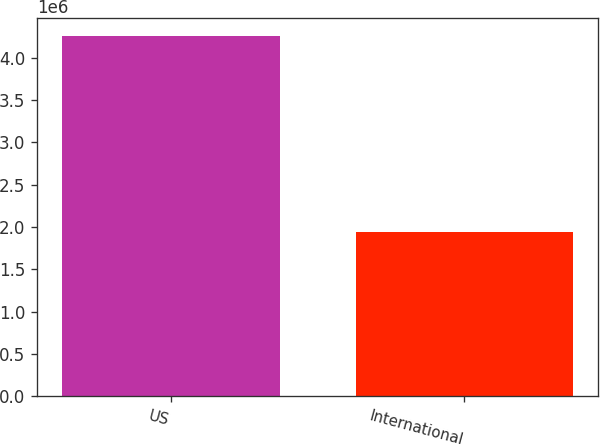<chart> <loc_0><loc_0><loc_500><loc_500><bar_chart><fcel>US<fcel>International<nl><fcel>4.256e+06<fcel>1.945e+06<nl></chart> 